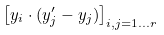<formula> <loc_0><loc_0><loc_500><loc_500>\left [ y _ { i } \cdot ( y ^ { \prime } _ { j } - y _ { j } ) \right ] _ { i , j = 1 \dots r }</formula> 